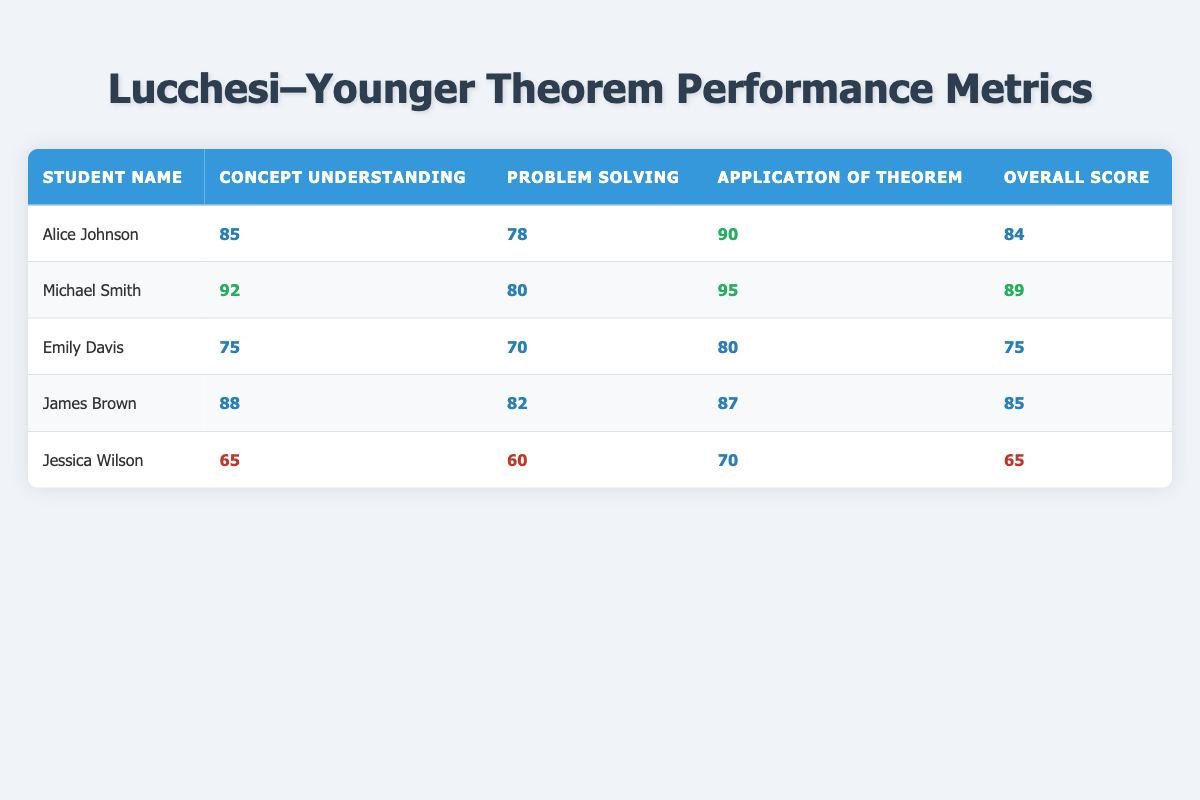What is Emily Davis's overall score? Emily Davis's overall score is listed in the "Overall Score" column of the table, which shows a score of 75 for her.
Answer: 75 Which student has the highest score in the "Application of Theorem" category? By examining the "Application of Theorem" column, Michael Smith has the highest score of 95 in this category, compared to the scores of other students.
Answer: Michael Smith What is the average concept understanding score of all students? The scores for concept understanding are 85, 92, 75, 88, and 65. To find the average, we sum these scores: (85 + 92 + 75 + 88 + 65) = 405. Dividing by the number of students (5), we get an average of 405/5 = 81.
Answer: 81 Did Jessica Wilson score above 70 in any category? In the table, Jessica Wilson's scores are 65 in Concept Understanding, 60 in Problem Solving, and 70 in Application of Theorem. She did not score above 70 in any of these categories.
Answer: No Who has the lowest overall score, and what is that score? By looking at the "Overall Score" column, we see that Jessica Wilson has the lowest overall score of 65, which is lower than the other students' scores.
Answer: Jessica Wilson, 65 What is the difference between the highest and lowest scores in problem solving? The highest score in Problem Solving is 82 (James Brown), and the lowest is 60 (Jessica Wilson). The difference is calculated as 82 - 60 = 22.
Answer: 22 How many students scored above 80 in the "Concept Understanding" category? From the table, the scores above 80 in the "Concept Understanding" category are 85 (Alice Johnson), 92 (Michael Smith), and 88 (James Brown). That gives us 3 students with scores above 80.
Answer: 3 Which student scored the same in both "Problem Solving" and "Application of Theorem" categories? Looking at the table, there is no student who has the same score in both the "Problem Solving" and "Application of Theorem" categories; they all have different scores.
Answer: None 